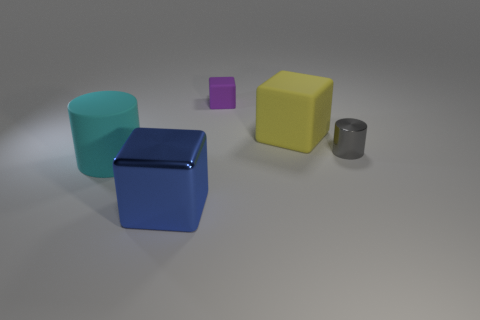What is the shape of the object on the right side of the big rubber object to the right of the shiny object that is in front of the cyan matte cylinder?
Offer a very short reply. Cylinder. What color is the cylinder that is the same material as the purple object?
Your answer should be compact. Cyan. There is a large rubber object that is right of the rubber thing to the left of the metallic thing on the left side of the small purple rubber object; what color is it?
Provide a succinct answer. Yellow. How many spheres are big green objects or blue shiny things?
Offer a very short reply. 0. Do the large metal cube and the tiny object that is to the left of the yellow object have the same color?
Offer a terse response. No. What color is the metallic block?
Ensure brevity in your answer.  Blue. What number of objects are purple metallic objects or large cyan rubber cylinders?
Offer a terse response. 1. There is a cylinder that is the same size as the purple rubber thing; what is it made of?
Provide a succinct answer. Metal. There is a metallic thing to the right of the tiny purple rubber thing; what size is it?
Make the answer very short. Small. What is the big yellow cube made of?
Ensure brevity in your answer.  Rubber. 